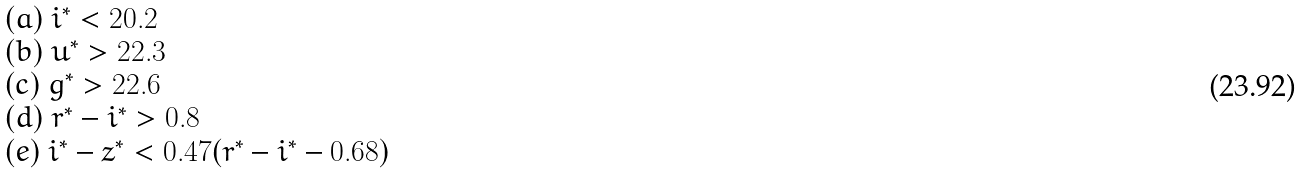<formula> <loc_0><loc_0><loc_500><loc_500>\begin{array} { l } ( a ) \ i ^ { * } < 2 0 . 2 \\ ( b ) \ u ^ { * } > 2 2 . 3 \\ ( c ) \ g ^ { * } > 2 2 . 6 \\ ( d ) \ r ^ { * } - i ^ { * } > 0 . 8 \\ ( e ) \ i ^ { * } - z ^ { * } < 0 . 4 7 ( r ^ { * } - i ^ { * } - 0 . 6 8 ) \end{array}</formula> 